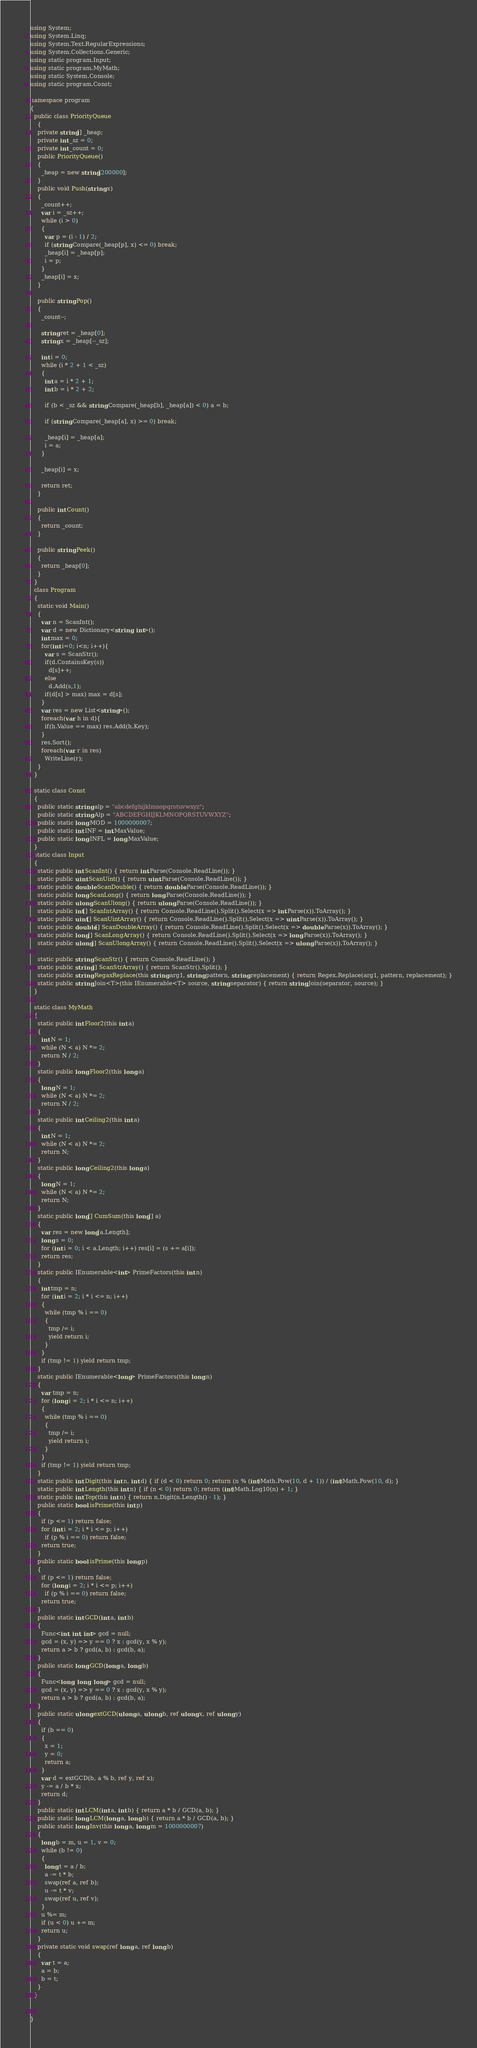<code> <loc_0><loc_0><loc_500><loc_500><_C#_>using System;
using System.Linq;
using System.Text.RegularExpressions;
using System.Collections.Generic;
using static program.Input;
using static program.MyMath;
using static System.Console;
using static program.Const;

namespace program
{
  public class PriorityQueue
    {
    private string[] _heap;
    private int _sz = 0;
    private int _count = 0;
    public PriorityQueue()
    {
      _heap = new string[200000];
    }
    public void Push(string x)
    {
      _count++;
      var i = _sz++;
      while (i > 0)
      {
        var p = (i - 1) / 2;
        if (string.Compare(_heap[p], x) <= 0) break;
        _heap[i] = _heap[p];
        i = p;
      }
      _heap[i] = x;
    }

    public string Pop()
    {
      _count--;

      string ret = _heap[0];
      string x = _heap[--_sz];

      int i = 0;
      while (i * 2 + 1 < _sz)
      {
        int a = i * 2 + 1;
        int b = i * 2 + 2;

        if (b < _sz && string.Compare(_heap[b], _heap[a]) < 0) a = b;

        if (string.Compare(_heap[a], x) >= 0) break;

        _heap[i] = _heap[a];
        i = a;
      }

      _heap[i] = x;

      return ret;
    }

    public int Count()
    {
      return _count;
    }

    public string Peek()
    {
      return _heap[0];
    }
  }
  class Program
  {
    static void Main()
    {
      var n = ScanInt();
      var d = new Dictionary<string, int>();
      int max = 0;
      for(int i=0; i<n; i++){
        var s = ScanStr();
        if(d.ContainsKey(s))
          d[s]++;
        else
          d.Add(s,1);
        if(d[s] > max) max = d[s];
      }
      var res = new List<string>();
      foreach(var h in d){
        if(h.Value == max) res.Add(h.Key);
      }
      res.Sort();
      foreach(var r in res)
        WriteLine(r);
    }
  }

  static class Const
  {
    public static string alp = "abcdefghijklmnopqrstuvwxyz";
    public static string Alp = "ABCDEFGHIJKLMNOPQRSTUVWXYZ";
    public static long MOD = 1000000007;
    public static int INF = int.MaxValue;
    public static long INFL = long.MaxValue;
  }
  static class Input
  {
    static public int ScanInt() { return int.Parse(Console.ReadLine()); }
    static public uint ScanUint() { return uint.Parse(Console.ReadLine()); }
    static public double ScanDouble() { return double.Parse(Console.ReadLine()); }
    static public long ScanLong() { return long.Parse(Console.ReadLine()); }
    static public ulong ScanUlong() { return ulong.Parse(Console.ReadLine()); }
    static public int[] ScanIntArray() { return Console.ReadLine().Split().Select(x => int.Parse(x)).ToArray(); }
    static public uint[] ScanUintArray() { return Console.ReadLine().Split().Select(x => uint.Parse(x)).ToArray(); }
    static public double[] ScanDoubleArray() { return Console.ReadLine().Split().Select(x => double.Parse(x)).ToArray(); }
    static public long[] ScanLongArray() { return Console.ReadLine().Split().Select(x => long.Parse(x)).ToArray(); }
    static public ulong[] ScanUlongArray() { return Console.ReadLine().Split().Select(x => ulong.Parse(x)).ToArray(); }

    static public string ScanStr() { return Console.ReadLine(); }
    static public string[] ScanStrArray() { return ScanStr().Split(); }
    static public string RegaxReplace(this string arg1, string pattern, string replacement) { return Regex.Replace(arg1, pattern, replacement); }
    static public string Join<T>(this IEnumerable<T> source, string separator) { return string.Join(separator, source); }
  }

  static class MyMath
  {
    static public int Floor2(this int a)
    {
      int N = 1;
      while (N < a) N *= 2;
      return N / 2;
    }
    static public long Floor2(this long a)
    {
      long N = 1;
      while (N < a) N *= 2;
      return N / 2;
    }
    static public int Ceiling2(this int a)
    {
      int N = 1;
      while (N < a) N *= 2;
      return N;
    }
    static public long Ceiling2(this long a)
    {
      long N = 1;
      while (N < a) N *= 2;
      return N;
    }
    static public long[] CumSum(this long[] a)
    {
      var res = new long[a.Length];
      long s = 0;
      for (int i = 0; i < a.Length; i++) res[i] = (s += a[i]);
      return res;
    }
    static public IEnumerable<int> PrimeFactors(this int n)
    {
      int tmp = n;
      for (int i = 2; i * i <= n; i++)
      {
        while (tmp % i == 0)
        {
          tmp /= i;
          yield return i;
        }
      }
      if (tmp != 1) yield return tmp;
    }
    static public IEnumerable<long> PrimeFactors(this long n)
    {
      var tmp = n;
      for (long i = 2; i * i <= n; i++)
      {
        while (tmp % i == 0)
        {
          tmp /= i;
          yield return i;
        }
      }
      if (tmp != 1) yield return tmp;
    }
    static public int Digit(this int n, int d) { if (d < 0) return 0; return (n % (int)Math.Pow(10, d + 1)) / (int)Math.Pow(10, d); }
    static public int Length(this int n) { if (n < 0) return 0; return (int)Math.Log10(n) + 1; }
    static public int Top(this int n) { return n.Digit(n.Length() - 1); }
    public static bool isPrime(this int p)
    {
      if (p <= 1) return false;
      for (int i = 2; i * i <= p; i++)
        if (p % i == 0) return false;
      return true;
    }
    public static bool isPrime(this long p)
    {
      if (p <= 1) return false;
      for (long i = 2; i * i <= p; i++)
        if (p % i == 0) return false;
      return true;
    }
    public static int GCD(int a, int b)
    {
      Func<int, int, int> gcd = null;
      gcd = (x, y) => y == 0 ? x : gcd(y, x % y);
      return a > b ? gcd(a, b) : gcd(b, a);
    }
    public static long GCD(long a, long b)
    {
      Func<long, long, long> gcd = null;
      gcd = (x, y) => y == 0 ? x : gcd(y, x % y);
      return a > b ? gcd(a, b) : gcd(b, a);
    }
    public static ulong extGCD(ulong a, ulong b, ref ulong x, ref ulong y)
    {
      if (b == 0)
      {
        x = 1;
        y = 0;
        return a;
      }
      var d = extGCD(b, a % b, ref y, ref x);
      y -= a / b * x;
      return d;
    }
    public static int LCM(int a, int b) { return a * b / GCD(a, b); }
    public static long LCM(long a, long b) { return a * b / GCD(a, b); }
    public static long Inv(this long a, long m = 1000000007)
    {
      long b = m, u = 1, v = 0;
      while (b != 0)
      {
        long t = a / b;
        a -= t * b;
        swap(ref a, ref b);
        u -= t * v;
        swap(ref u, ref v);
      }
      u %= m;
      if (u < 0) u += m;
      return u;
    }
    private static void swap(ref long a, ref long b)
    {
      var t = a;
      a = b;
      b = t;
    }
  }


}
</code> 